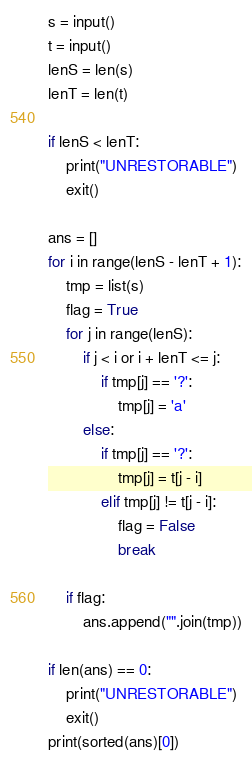<code> <loc_0><loc_0><loc_500><loc_500><_Python_>s = input()
t = input()
lenS = len(s)
lenT = len(t)

if lenS < lenT:
    print("UNRESTORABLE")
    exit()

ans = []
for i in range(lenS - lenT + 1):
    tmp = list(s)
    flag = True
    for j in range(lenS):
        if j < i or i + lenT <= j:
            if tmp[j] == '?':
                tmp[j] = 'a'
        else:
            if tmp[j] == '?':
                tmp[j] = t[j - i]
            elif tmp[j] != t[j - i]:
                flag = False
                break

    if flag:
        ans.append("".join(tmp))

if len(ans) == 0:
    print("UNRESTORABLE")
    exit()
print(sorted(ans)[0])
</code> 